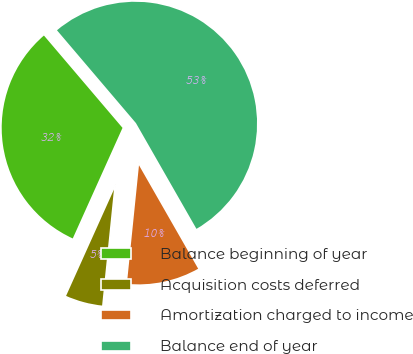<chart> <loc_0><loc_0><loc_500><loc_500><pie_chart><fcel>Balance beginning of year<fcel>Acquisition costs deferred<fcel>Amortization charged to income<fcel>Balance end of year<nl><fcel>32.05%<fcel>5.11%<fcel>9.89%<fcel>52.95%<nl></chart> 